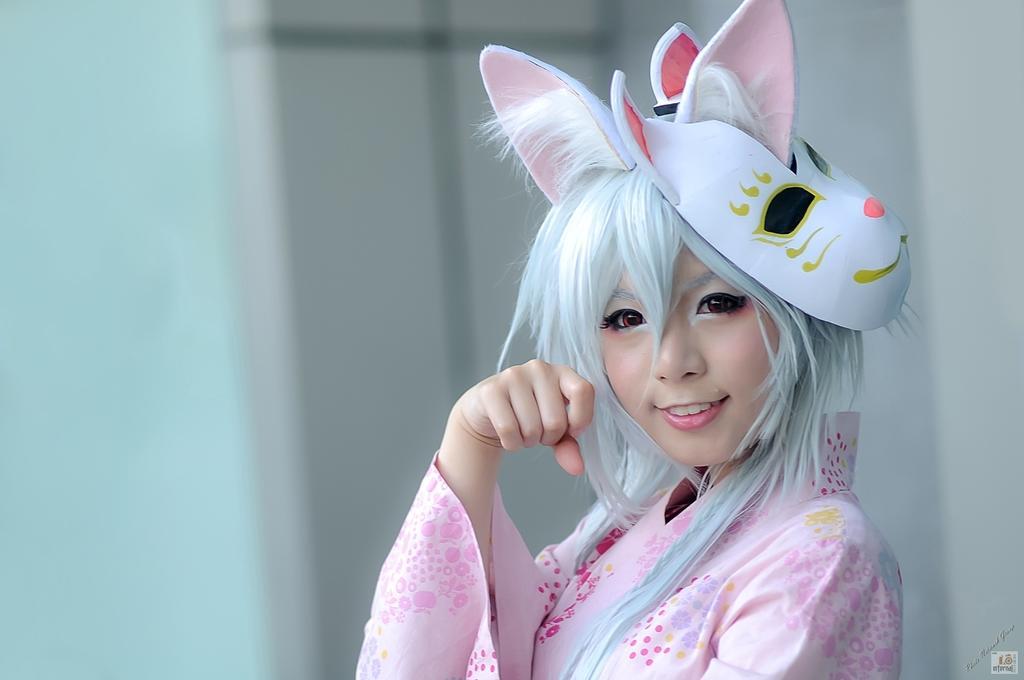Can you describe this image briefly? In front of the image there is a person having a smile on her face. There is some text and watermark at the bottom of the image. 